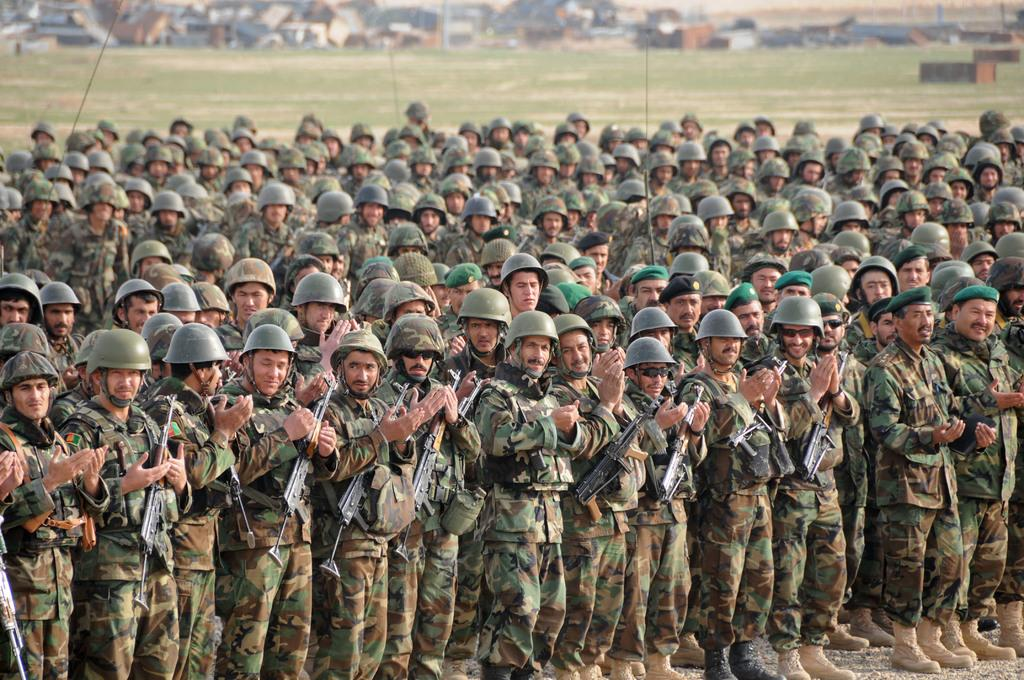What are the people in the image wearing? The people in the image are wearing military dress. What are the people holding in the image? The people are holding weapons. What can be seen in the background of the image? There are houses in the background of the image. What type of trousers are the people wearing in the image? There is no specific information about the type of trousers the people are wearing in the image. --- Facts: 1. There is a person in the image. 2. The person is holding a book. 3. The book is titled "The Art of War" by Sun Tzu. 4. The person is sitting on a chair. 5. The background of the image is a library. Absurd Topics: elephant, piano, ocean Conversation: What is the person in the image holding? The person is holding a book. What is the title of the book the person is holding? The book is titled "The Art of War" by Sun Tzu. What is the person in the image sitting on? The person is sitting on a chair. What can be seen in the background of the image? The background of the image is a library. Reasoning: Let's think step by step in order to produce the conversation. We start by identifying the main subject in the image, which is the person. Then, we describe what the person is holding, which is a book. Next, we mention the title of the book, which is "The Art of War" by Sun Tzu. After that, we observe the person's position, which is sitting on a chair. Finally, we describe the background of the image, which is a library. Each question is designed to elicit a specific detail about the image that is known from the provided facts. Absurd Question/Answer: Can you see an elephant playing a piano in the image? No, there is no elephant playing a piano in the image. --- Facts: 1. There is a dog in the image. 2. The dog is a golden retriever. 3. The dog is sitting on a mat. 4. The dog has a red collar. 5. The background of the image is a park. Absurd Topics: giraffe, roller coaster, amusement park Conversation: What type of animal is in the image? There is a dog in the image. What breed of dog is in the image? The dog is a golden retriever. What position is the dog in the image? The dog is sitting on a mat. What can be seen on the dog's neck in the image? The dog has a red collar. What can be seen in the background of the image? The background of the image is a park. Reasoning: Let's think step by step in order 